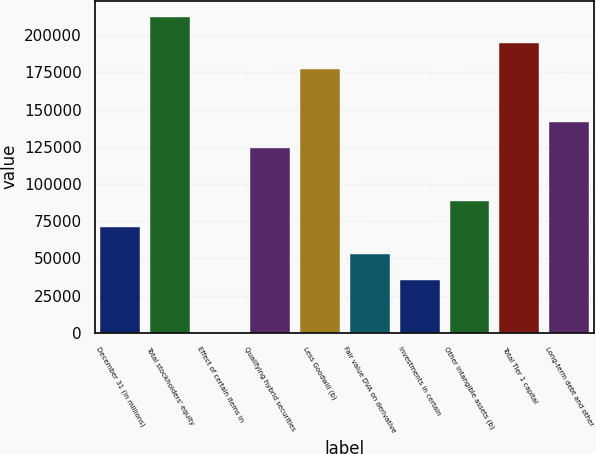<chart> <loc_0><loc_0><loc_500><loc_500><bar_chart><fcel>December 31 (in millions)<fcel>Total stockholders' equity<fcel>Effect of certain items in<fcel>Qualifying hybrid securities<fcel>Less Goodwill (b)<fcel>Fair value DVA on derivative<fcel>Investments in certain<fcel>Other intangible assets (b)<fcel>Total Tier 1 capital<fcel>Long-term debt and other<nl><fcel>70874.2<fcel>212473<fcel>75<fcel>123974<fcel>177073<fcel>53174.4<fcel>35474.6<fcel>88574<fcel>194773<fcel>141673<nl></chart> 